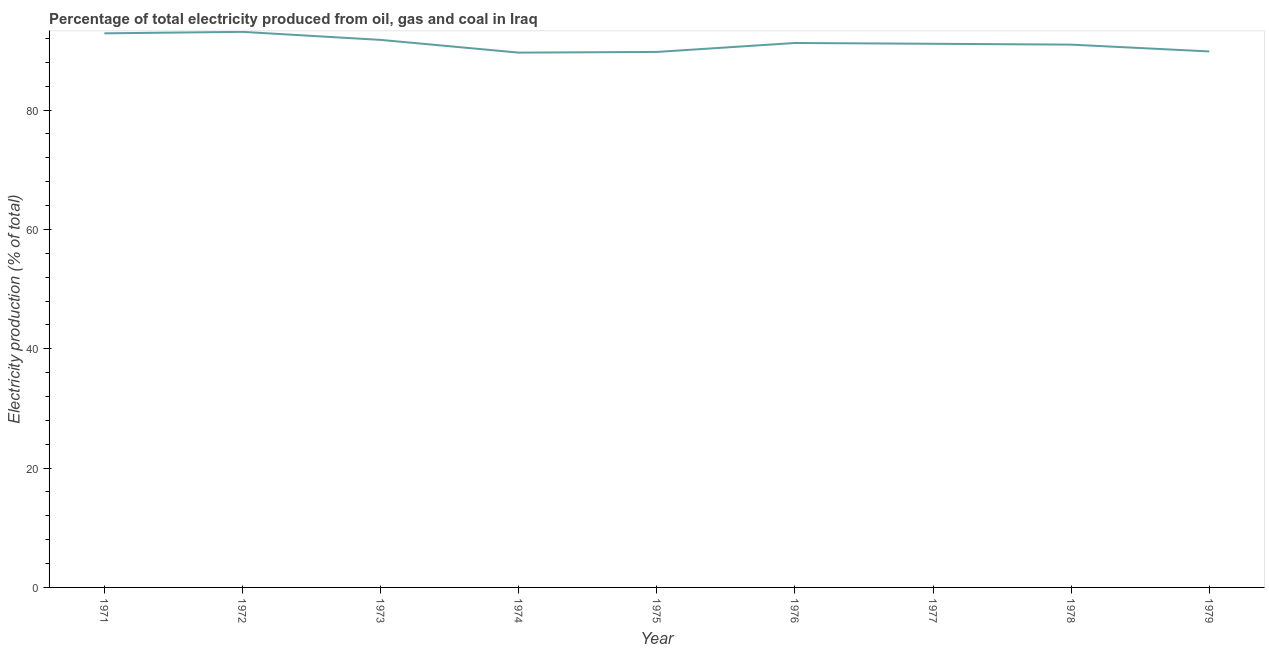What is the electricity production in 1977?
Provide a succinct answer. 91.11. Across all years, what is the maximum electricity production?
Your response must be concise. 93.1. Across all years, what is the minimum electricity production?
Your answer should be compact. 89.62. In which year was the electricity production maximum?
Offer a terse response. 1972. In which year was the electricity production minimum?
Provide a succinct answer. 1974. What is the sum of the electricity production?
Offer a very short reply. 820.21. What is the difference between the electricity production in 1971 and 1973?
Keep it short and to the point. 1.1. What is the average electricity production per year?
Your response must be concise. 91.13. What is the median electricity production?
Offer a very short reply. 91.11. Do a majority of the years between 1975 and 1977 (inclusive) have electricity production greater than 12 %?
Provide a succinct answer. Yes. What is the ratio of the electricity production in 1971 to that in 1976?
Offer a terse response. 1.02. Is the electricity production in 1971 less than that in 1975?
Make the answer very short. No. Is the difference between the electricity production in 1973 and 1978 greater than the difference between any two years?
Ensure brevity in your answer.  No. What is the difference between the highest and the second highest electricity production?
Provide a succinct answer. 0.25. Is the sum of the electricity production in 1971 and 1976 greater than the maximum electricity production across all years?
Your answer should be very brief. Yes. What is the difference between the highest and the lowest electricity production?
Your answer should be compact. 3.48. Does the electricity production monotonically increase over the years?
Provide a short and direct response. No. What is the difference between two consecutive major ticks on the Y-axis?
Ensure brevity in your answer.  20. Does the graph contain grids?
Keep it short and to the point. No. What is the title of the graph?
Offer a terse response. Percentage of total electricity produced from oil, gas and coal in Iraq. What is the label or title of the Y-axis?
Keep it short and to the point. Electricity production (% of total). What is the Electricity production (% of total) in 1971?
Your answer should be very brief. 92.86. What is the Electricity production (% of total) in 1972?
Offer a very short reply. 93.1. What is the Electricity production (% of total) of 1973?
Offer a very short reply. 91.76. What is the Electricity production (% of total) of 1974?
Make the answer very short. 89.62. What is the Electricity production (% of total) of 1975?
Your answer should be very brief. 89.74. What is the Electricity production (% of total) of 1976?
Your answer should be very brief. 91.24. What is the Electricity production (% of total) of 1977?
Provide a short and direct response. 91.11. What is the Electricity production (% of total) of 1978?
Provide a short and direct response. 90.96. What is the Electricity production (% of total) in 1979?
Offer a terse response. 89.82. What is the difference between the Electricity production (% of total) in 1971 and 1972?
Ensure brevity in your answer.  -0.25. What is the difference between the Electricity production (% of total) in 1971 and 1973?
Your answer should be very brief. 1.1. What is the difference between the Electricity production (% of total) in 1971 and 1974?
Your answer should be compact. 3.23. What is the difference between the Electricity production (% of total) in 1971 and 1975?
Provide a short and direct response. 3.12. What is the difference between the Electricity production (% of total) in 1971 and 1976?
Your answer should be very brief. 1.62. What is the difference between the Electricity production (% of total) in 1971 and 1977?
Keep it short and to the point. 1.75. What is the difference between the Electricity production (% of total) in 1971 and 1978?
Give a very brief answer. 1.89. What is the difference between the Electricity production (% of total) in 1971 and 1979?
Make the answer very short. 3.03. What is the difference between the Electricity production (% of total) in 1972 and 1973?
Your answer should be compact. 1.34. What is the difference between the Electricity production (% of total) in 1972 and 1974?
Offer a terse response. 3.48. What is the difference between the Electricity production (% of total) in 1972 and 1975?
Your answer should be compact. 3.36. What is the difference between the Electricity production (% of total) in 1972 and 1976?
Provide a short and direct response. 1.86. What is the difference between the Electricity production (% of total) in 1972 and 1977?
Make the answer very short. 2. What is the difference between the Electricity production (% of total) in 1972 and 1978?
Your response must be concise. 2.14. What is the difference between the Electricity production (% of total) in 1972 and 1979?
Provide a succinct answer. 3.28. What is the difference between the Electricity production (% of total) in 1973 and 1974?
Offer a very short reply. 2.14. What is the difference between the Electricity production (% of total) in 1973 and 1975?
Provide a short and direct response. 2.02. What is the difference between the Electricity production (% of total) in 1973 and 1976?
Offer a terse response. 0.52. What is the difference between the Electricity production (% of total) in 1973 and 1977?
Ensure brevity in your answer.  0.65. What is the difference between the Electricity production (% of total) in 1973 and 1978?
Your answer should be very brief. 0.8. What is the difference between the Electricity production (% of total) in 1973 and 1979?
Your response must be concise. 1.94. What is the difference between the Electricity production (% of total) in 1974 and 1975?
Offer a terse response. -0.12. What is the difference between the Electricity production (% of total) in 1974 and 1976?
Make the answer very short. -1.61. What is the difference between the Electricity production (% of total) in 1974 and 1977?
Make the answer very short. -1.48. What is the difference between the Electricity production (% of total) in 1974 and 1978?
Offer a very short reply. -1.34. What is the difference between the Electricity production (% of total) in 1974 and 1979?
Ensure brevity in your answer.  -0.2. What is the difference between the Electricity production (% of total) in 1975 and 1976?
Provide a succinct answer. -1.5. What is the difference between the Electricity production (% of total) in 1975 and 1977?
Keep it short and to the point. -1.37. What is the difference between the Electricity production (% of total) in 1975 and 1978?
Make the answer very short. -1.22. What is the difference between the Electricity production (% of total) in 1975 and 1979?
Offer a very short reply. -0.08. What is the difference between the Electricity production (% of total) in 1976 and 1977?
Your answer should be compact. 0.13. What is the difference between the Electricity production (% of total) in 1976 and 1978?
Keep it short and to the point. 0.28. What is the difference between the Electricity production (% of total) in 1976 and 1979?
Offer a terse response. 1.42. What is the difference between the Electricity production (% of total) in 1977 and 1978?
Keep it short and to the point. 0.14. What is the difference between the Electricity production (% of total) in 1977 and 1979?
Ensure brevity in your answer.  1.28. What is the difference between the Electricity production (% of total) in 1978 and 1979?
Offer a terse response. 1.14. What is the ratio of the Electricity production (% of total) in 1971 to that in 1972?
Your answer should be compact. 1. What is the ratio of the Electricity production (% of total) in 1971 to that in 1974?
Your answer should be compact. 1.04. What is the ratio of the Electricity production (% of total) in 1971 to that in 1975?
Your answer should be very brief. 1.03. What is the ratio of the Electricity production (% of total) in 1971 to that in 1976?
Give a very brief answer. 1.02. What is the ratio of the Electricity production (% of total) in 1971 to that in 1977?
Provide a succinct answer. 1.02. What is the ratio of the Electricity production (% of total) in 1971 to that in 1979?
Offer a very short reply. 1.03. What is the ratio of the Electricity production (% of total) in 1972 to that in 1973?
Give a very brief answer. 1.01. What is the ratio of the Electricity production (% of total) in 1972 to that in 1974?
Offer a terse response. 1.04. What is the ratio of the Electricity production (% of total) in 1972 to that in 1977?
Give a very brief answer. 1.02. What is the ratio of the Electricity production (% of total) in 1972 to that in 1978?
Offer a terse response. 1.02. What is the ratio of the Electricity production (% of total) in 1972 to that in 1979?
Make the answer very short. 1.04. What is the ratio of the Electricity production (% of total) in 1973 to that in 1975?
Keep it short and to the point. 1.02. What is the ratio of the Electricity production (% of total) in 1973 to that in 1976?
Provide a short and direct response. 1.01. What is the ratio of the Electricity production (% of total) in 1973 to that in 1977?
Provide a succinct answer. 1.01. What is the ratio of the Electricity production (% of total) in 1973 to that in 1979?
Your answer should be compact. 1.02. What is the ratio of the Electricity production (% of total) in 1974 to that in 1976?
Your answer should be compact. 0.98. What is the ratio of the Electricity production (% of total) in 1974 to that in 1979?
Your answer should be compact. 1. What is the ratio of the Electricity production (% of total) in 1975 to that in 1977?
Your answer should be compact. 0.98. What is the ratio of the Electricity production (% of total) in 1976 to that in 1977?
Ensure brevity in your answer.  1. What is the ratio of the Electricity production (% of total) in 1976 to that in 1979?
Provide a succinct answer. 1.02. What is the ratio of the Electricity production (% of total) in 1977 to that in 1979?
Provide a short and direct response. 1.01. What is the ratio of the Electricity production (% of total) in 1978 to that in 1979?
Ensure brevity in your answer.  1.01. 